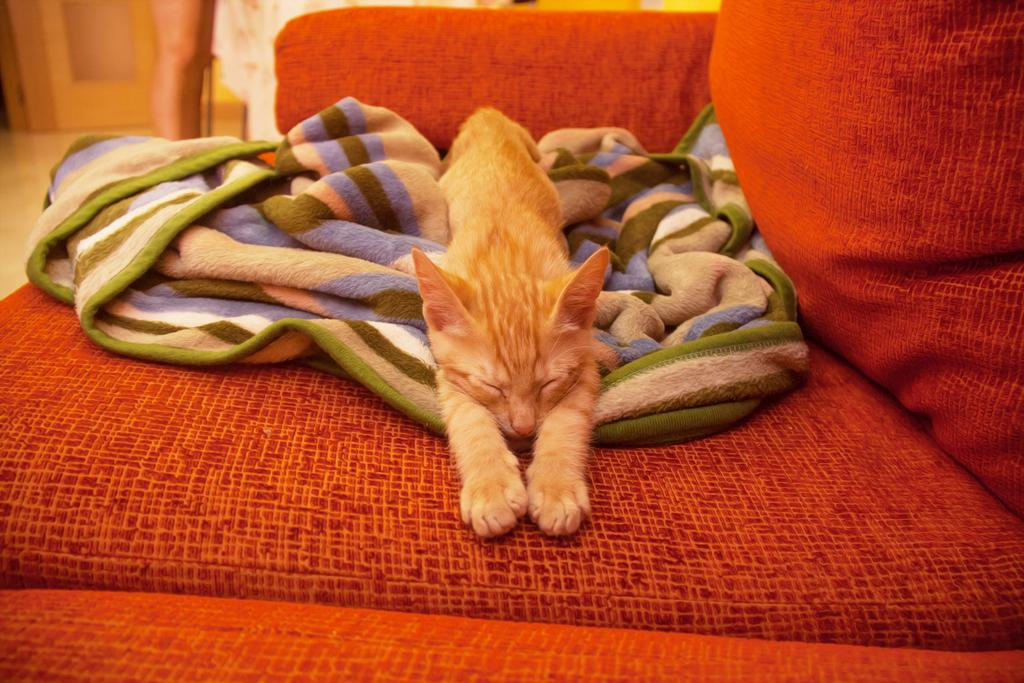What type of animal is in the image? There is a cat in the image. Where is the cat located? The cat is lying on a sofa. What is under the cat? There is a blanket under the cat. What color is the sofa? The sofa is orange in color. What direction is the bat flying in the image? There is no bat present in the image. What scientific discovery is depicted in the image? There is no scientific discovery depicted in the image. 